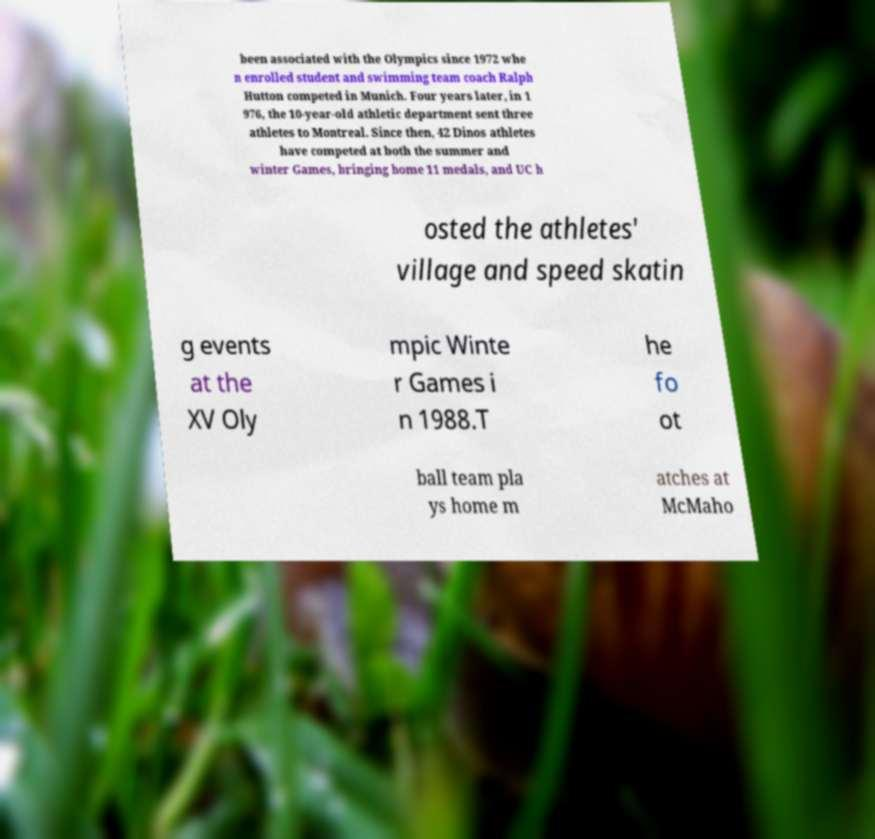Can you accurately transcribe the text from the provided image for me? been associated with the Olympics since 1972 whe n enrolled student and swimming team coach Ralph Hutton competed in Munich. Four years later, in 1 976, the 10-year-old athletic department sent three athletes to Montreal. Since then, 42 Dinos athletes have competed at both the summer and winter Games, bringing home 11 medals, and UC h osted the athletes' village and speed skatin g events at the XV Oly mpic Winte r Games i n 1988.T he fo ot ball team pla ys home m atches at McMaho 